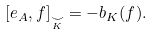Convert formula to latex. <formula><loc_0><loc_0><loc_500><loc_500>[ e _ { A } , f ] _ { \underset { K } { \smile } } = - b _ { K } ( f ) .</formula> 